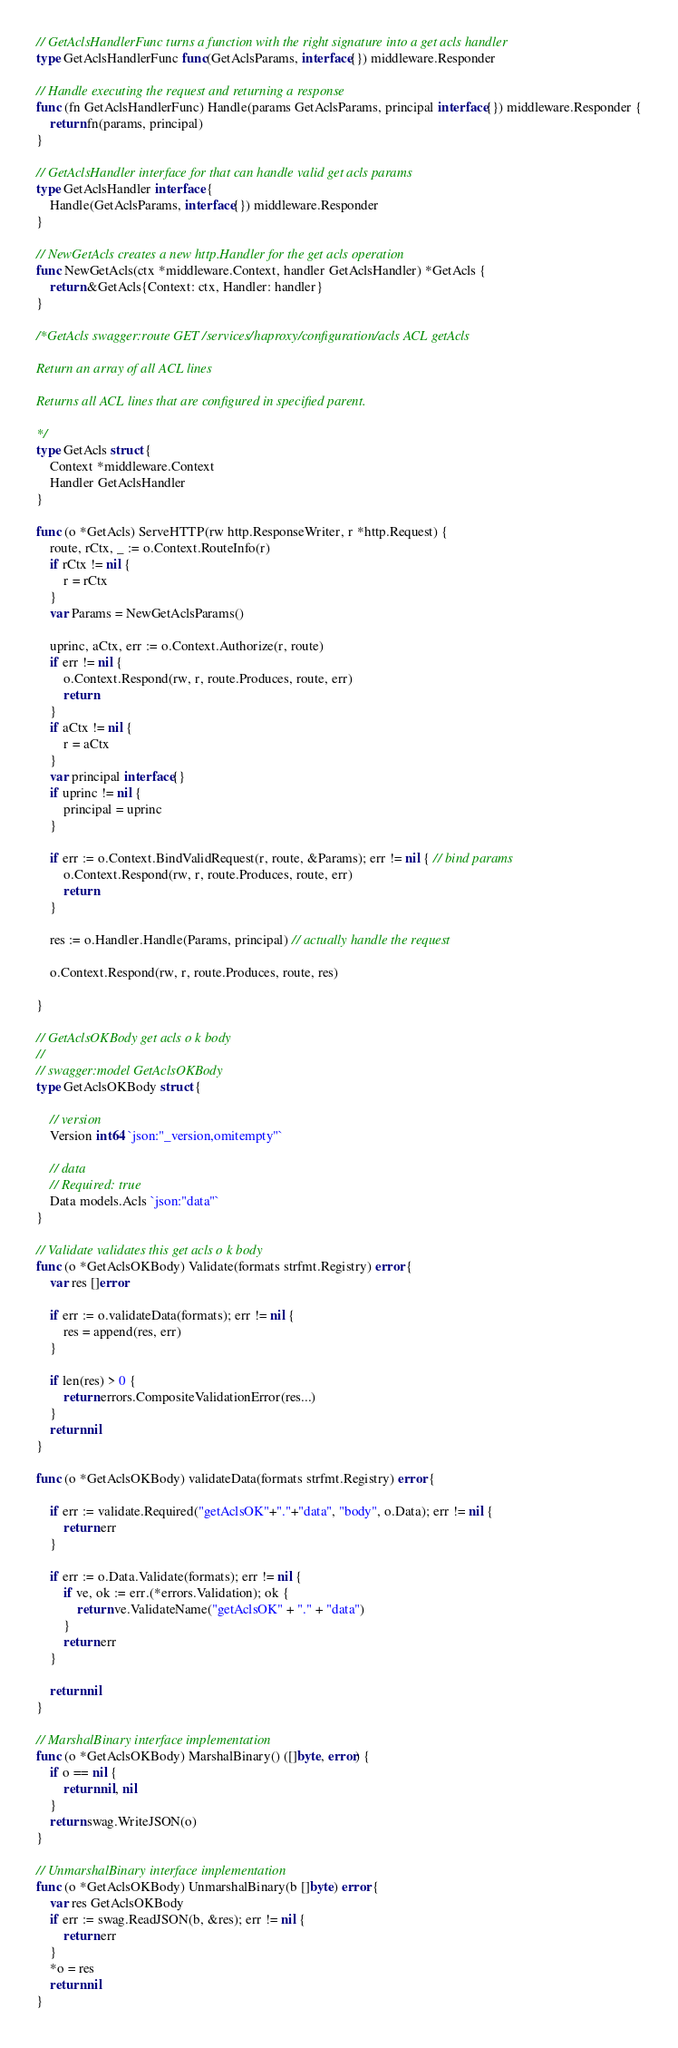<code> <loc_0><loc_0><loc_500><loc_500><_Go_>// GetAclsHandlerFunc turns a function with the right signature into a get acls handler
type GetAclsHandlerFunc func(GetAclsParams, interface{}) middleware.Responder

// Handle executing the request and returning a response
func (fn GetAclsHandlerFunc) Handle(params GetAclsParams, principal interface{}) middleware.Responder {
	return fn(params, principal)
}

// GetAclsHandler interface for that can handle valid get acls params
type GetAclsHandler interface {
	Handle(GetAclsParams, interface{}) middleware.Responder
}

// NewGetAcls creates a new http.Handler for the get acls operation
func NewGetAcls(ctx *middleware.Context, handler GetAclsHandler) *GetAcls {
	return &GetAcls{Context: ctx, Handler: handler}
}

/*GetAcls swagger:route GET /services/haproxy/configuration/acls ACL getAcls

Return an array of all ACL lines

Returns all ACL lines that are configured in specified parent.

*/
type GetAcls struct {
	Context *middleware.Context
	Handler GetAclsHandler
}

func (o *GetAcls) ServeHTTP(rw http.ResponseWriter, r *http.Request) {
	route, rCtx, _ := o.Context.RouteInfo(r)
	if rCtx != nil {
		r = rCtx
	}
	var Params = NewGetAclsParams()

	uprinc, aCtx, err := o.Context.Authorize(r, route)
	if err != nil {
		o.Context.Respond(rw, r, route.Produces, route, err)
		return
	}
	if aCtx != nil {
		r = aCtx
	}
	var principal interface{}
	if uprinc != nil {
		principal = uprinc
	}

	if err := o.Context.BindValidRequest(r, route, &Params); err != nil { // bind params
		o.Context.Respond(rw, r, route.Produces, route, err)
		return
	}

	res := o.Handler.Handle(Params, principal) // actually handle the request

	o.Context.Respond(rw, r, route.Produces, route, res)

}

// GetAclsOKBody get acls o k body
//
// swagger:model GetAclsOKBody
type GetAclsOKBody struct {

	// version
	Version int64 `json:"_version,omitempty"`

	// data
	// Required: true
	Data models.Acls `json:"data"`
}

// Validate validates this get acls o k body
func (o *GetAclsOKBody) Validate(formats strfmt.Registry) error {
	var res []error

	if err := o.validateData(formats); err != nil {
		res = append(res, err)
	}

	if len(res) > 0 {
		return errors.CompositeValidationError(res...)
	}
	return nil
}

func (o *GetAclsOKBody) validateData(formats strfmt.Registry) error {

	if err := validate.Required("getAclsOK"+"."+"data", "body", o.Data); err != nil {
		return err
	}

	if err := o.Data.Validate(formats); err != nil {
		if ve, ok := err.(*errors.Validation); ok {
			return ve.ValidateName("getAclsOK" + "." + "data")
		}
		return err
	}

	return nil
}

// MarshalBinary interface implementation
func (o *GetAclsOKBody) MarshalBinary() ([]byte, error) {
	if o == nil {
		return nil, nil
	}
	return swag.WriteJSON(o)
}

// UnmarshalBinary interface implementation
func (o *GetAclsOKBody) UnmarshalBinary(b []byte) error {
	var res GetAclsOKBody
	if err := swag.ReadJSON(b, &res); err != nil {
		return err
	}
	*o = res
	return nil
}
</code> 